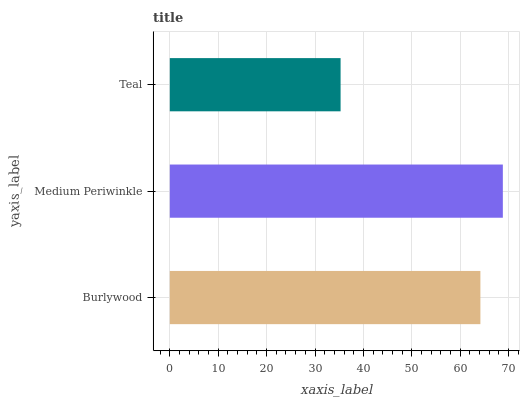Is Teal the minimum?
Answer yes or no. Yes. Is Medium Periwinkle the maximum?
Answer yes or no. Yes. Is Medium Periwinkle the minimum?
Answer yes or no. No. Is Teal the maximum?
Answer yes or no. No. Is Medium Periwinkle greater than Teal?
Answer yes or no. Yes. Is Teal less than Medium Periwinkle?
Answer yes or no. Yes. Is Teal greater than Medium Periwinkle?
Answer yes or no. No. Is Medium Periwinkle less than Teal?
Answer yes or no. No. Is Burlywood the high median?
Answer yes or no. Yes. Is Burlywood the low median?
Answer yes or no. Yes. Is Teal the high median?
Answer yes or no. No. Is Teal the low median?
Answer yes or no. No. 